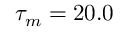<formula> <loc_0><loc_0><loc_500><loc_500>\tau _ { m } = 2 0 . 0</formula> 